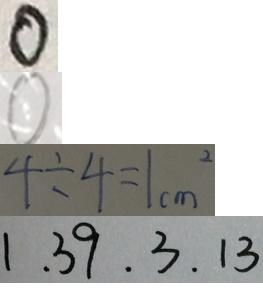Convert formula to latex. <formula><loc_0><loc_0><loc_500><loc_500>0 
 0 
 4 \div 4 = 1 c m ^ { 2 } 
 1 . 3 9 . 3 . 1 3</formula> 